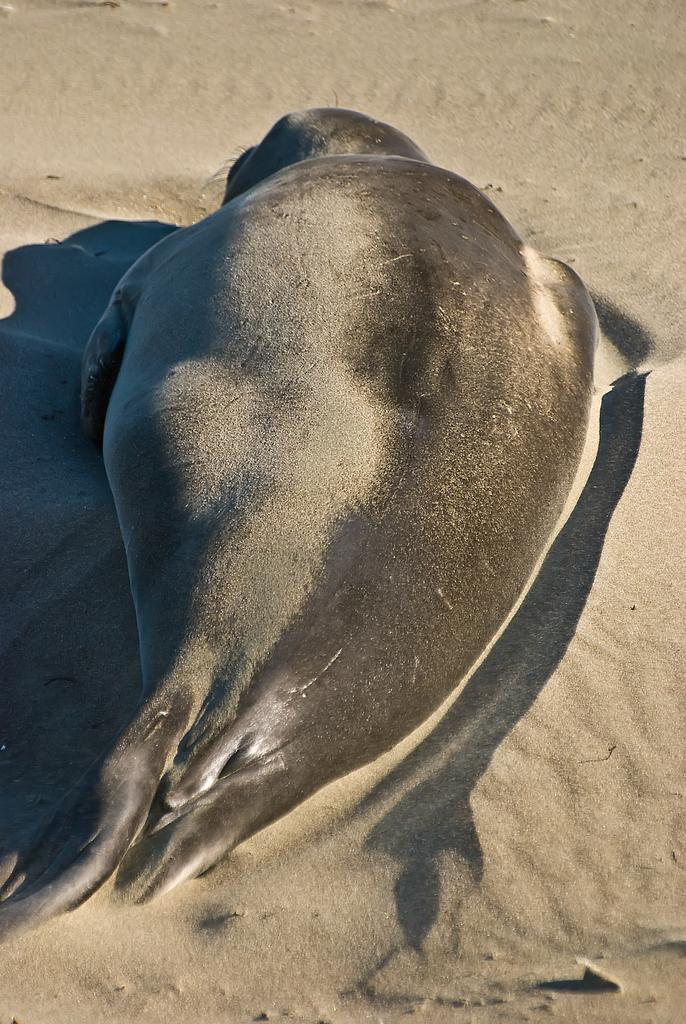What animal is present in the image? There is a seal in the image. Where is the seal located? The seal is on the sand. What type of punishment is being administered to the seal in the image? There is no punishment being administered to the seal in the image; it is simply resting on the sand. 